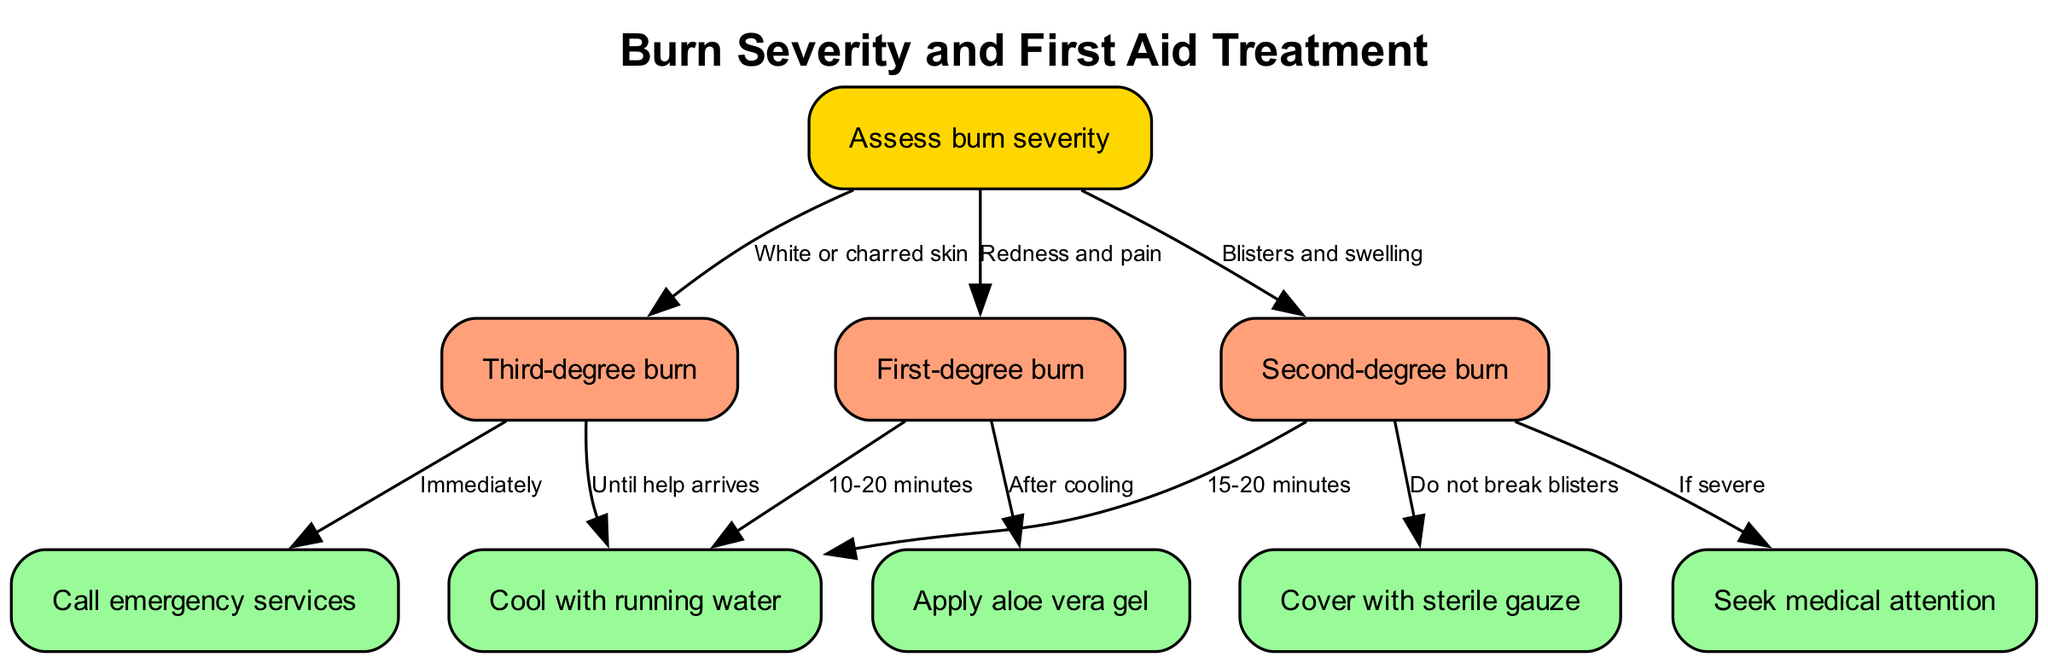What is the first step in the flowchart? The first node in the flowchart is "Assess burn severity," indicating that this is the initial action to take when dealing with a burn.
Answer: Assess burn severity How many types of burns are depicted in the diagram? There are three types of burns specified in the diagram: first-degree burn, second-degree burn, and third-degree burn, which makes a total of three types.
Answer: Three What should you do for a first-degree burn after cooling? According to the flowchart, after cooling a first-degree burn, you should apply aloe vera gel.
Answer: Apply aloe vera gel What immediate action is recommended for a third-degree burn? The diagram indicates that for a third-degree burn, you should call emergency services immediately.
Answer: Call emergency services What is the cooling time suggested for a second-degree burn? The flowchart specifies that you should cool a second-degree burn with running water for 15-20 minutes.
Answer: 15-20 minutes What should not be done when treating a second-degree burn? The flowchart specifies that you should not break blisters when treating a second-degree burn, as this can worsen the injury.
Answer: Do not break blisters What type of burn is described by "White or charred skin"? The diagram defines "White or charred skin" as a characteristic of a third-degree burn, indicating its severity.
Answer: Third-degree burn How should a first-degree burn ideally be covered? The flowchart does not indicate covering a first-degree burn with gauze; instead, it suggests applying aloe vera gel after cooling.
Answer: Apply aloe vera gel What is the follow-up action for a second-degree burn if it is severe? For a second-degree burn, if it is severe, the diagram indicates that you should seek medical attention.
Answer: Seek medical attention 